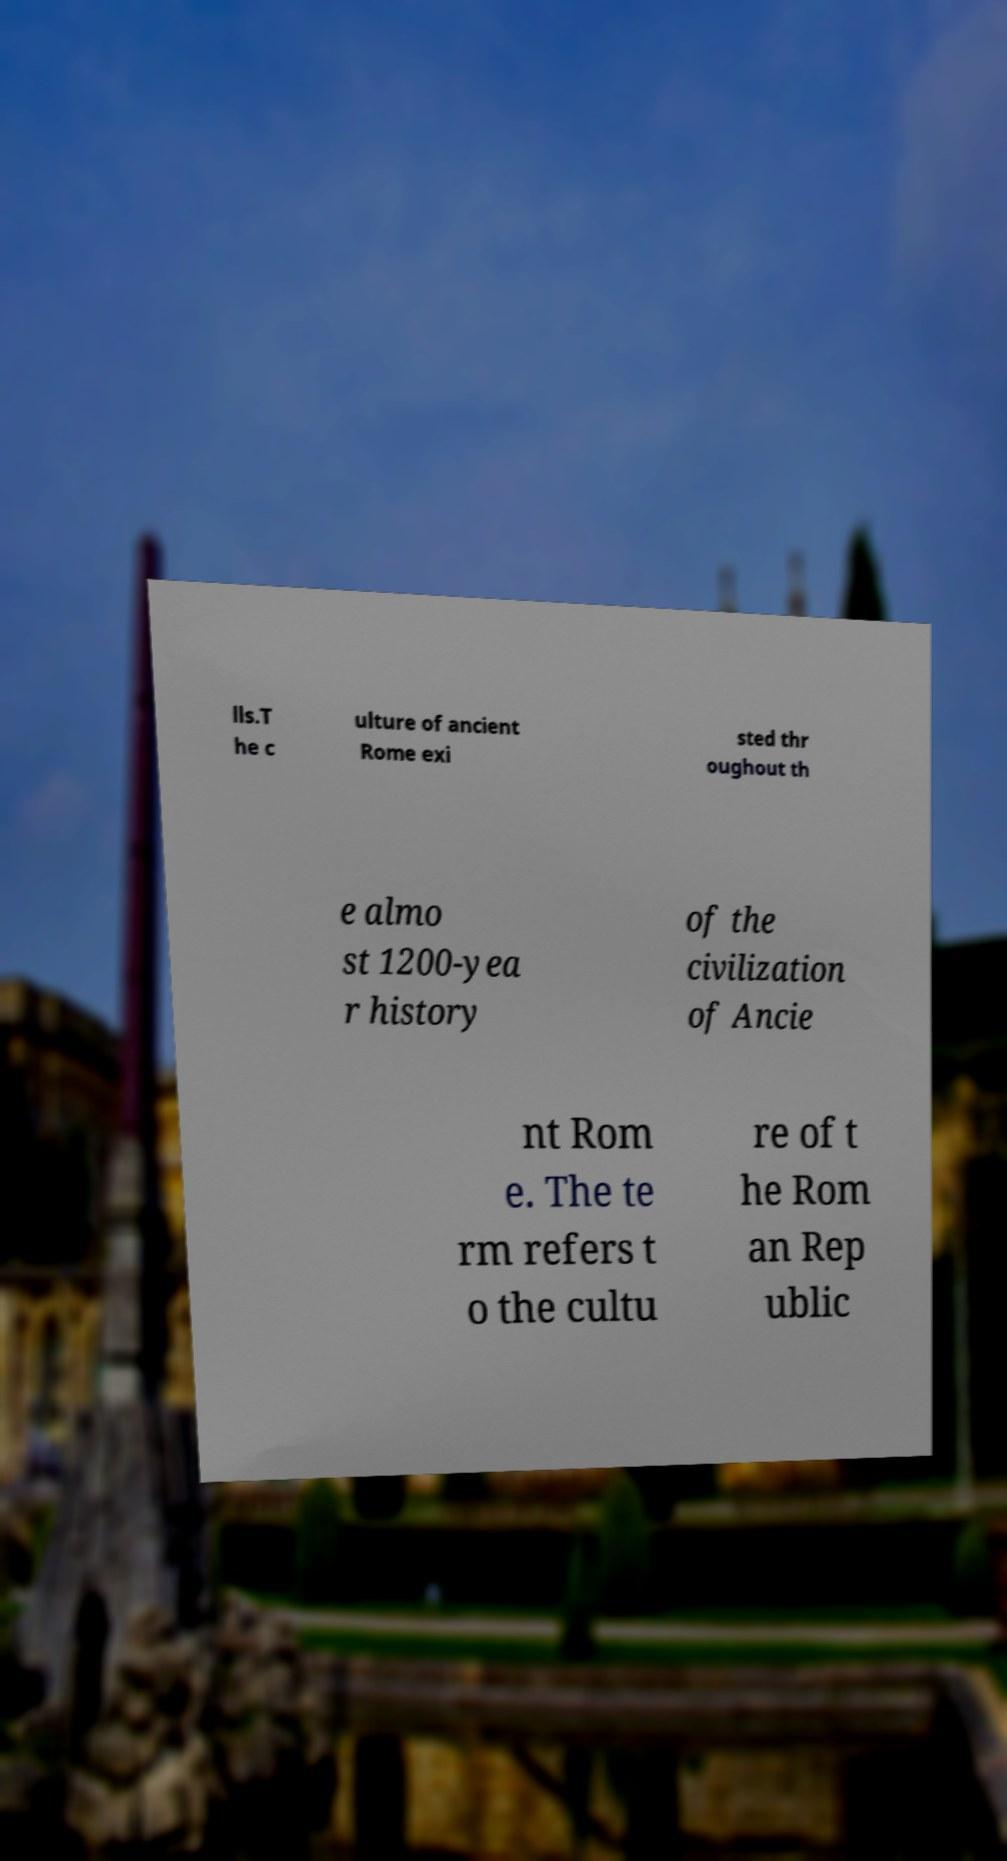For documentation purposes, I need the text within this image transcribed. Could you provide that? lls.T he c ulture of ancient Rome exi sted thr oughout th e almo st 1200-yea r history of the civilization of Ancie nt Rom e. The te rm refers t o the cultu re of t he Rom an Rep ublic 